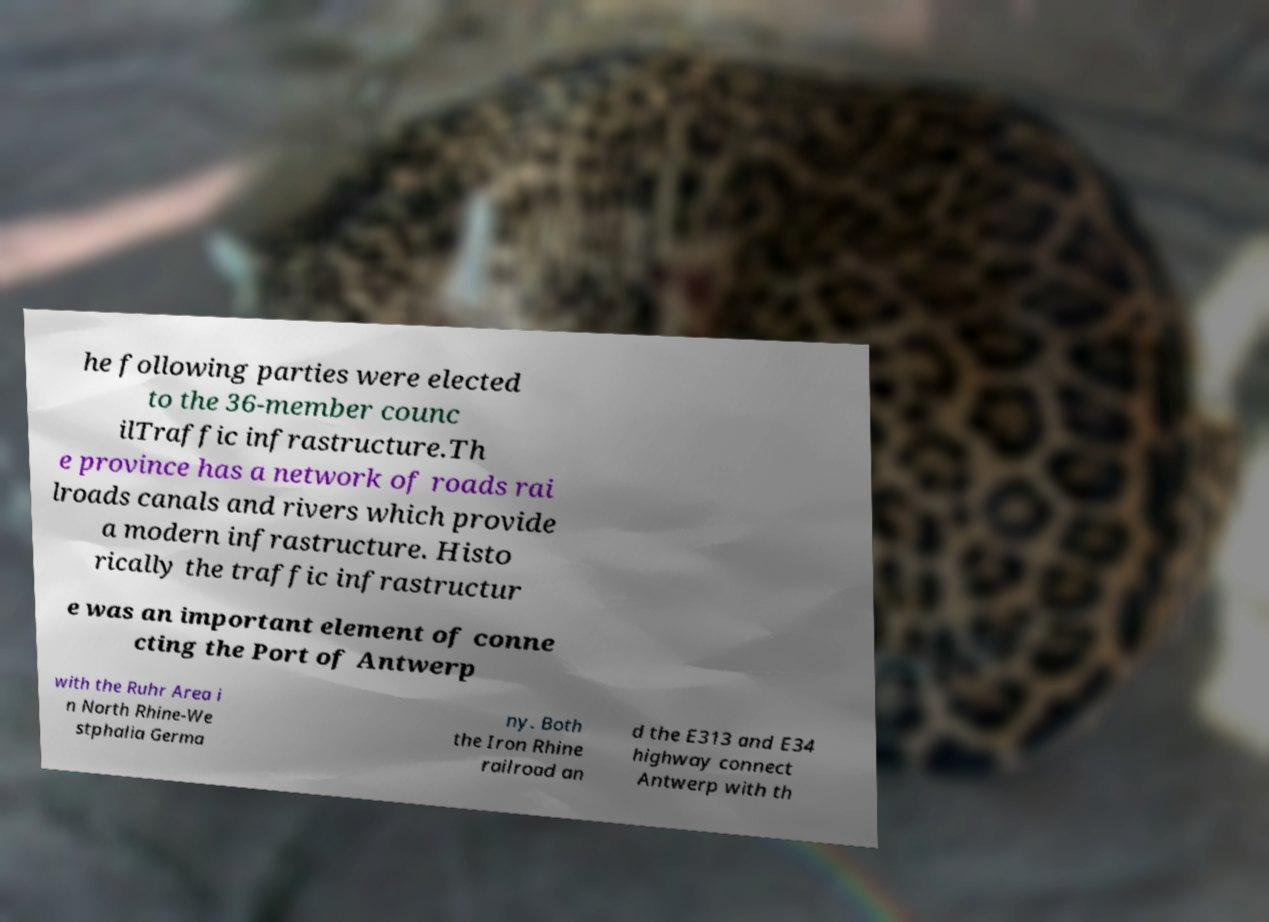Can you read and provide the text displayed in the image?This photo seems to have some interesting text. Can you extract and type it out for me? he following parties were elected to the 36-member counc ilTraffic infrastructure.Th e province has a network of roads rai lroads canals and rivers which provide a modern infrastructure. Histo rically the traffic infrastructur e was an important element of conne cting the Port of Antwerp with the Ruhr Area i n North Rhine-We stphalia Germa ny. Both the Iron Rhine railroad an d the E313 and E34 highway connect Antwerp with th 